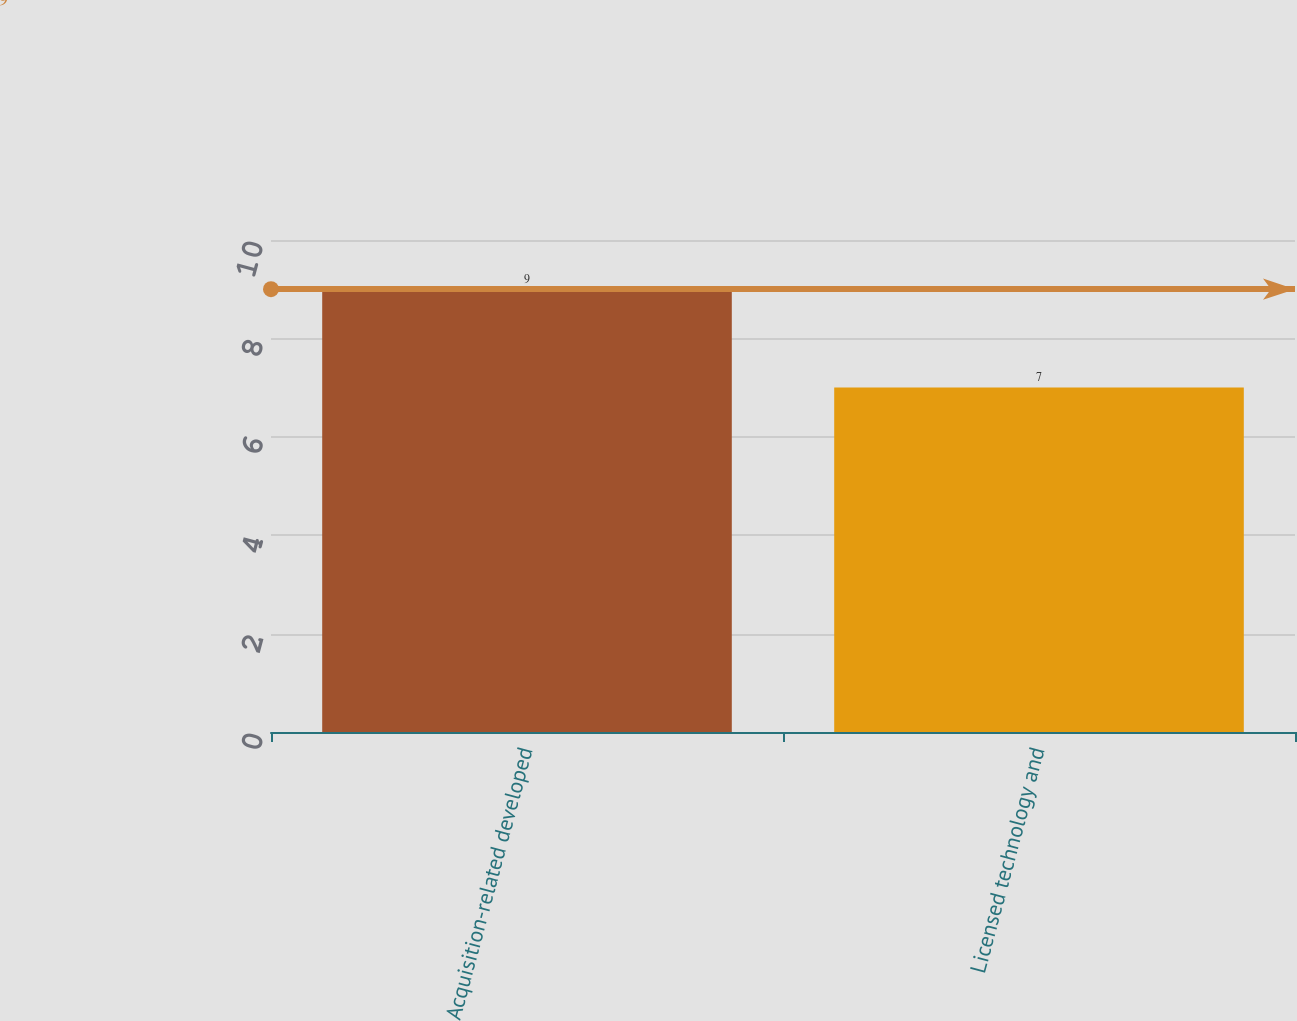<chart> <loc_0><loc_0><loc_500><loc_500><bar_chart><fcel>Acquisition-related developed<fcel>Licensed technology and<nl><fcel>9<fcel>7<nl></chart> 